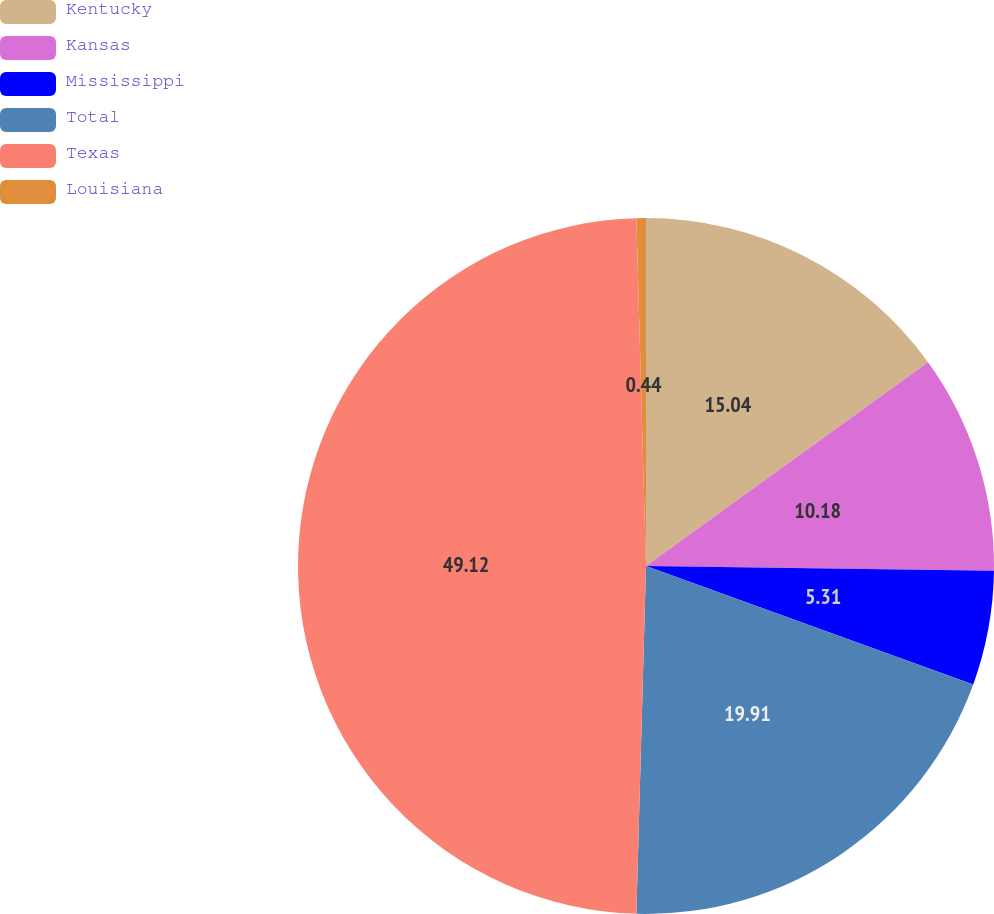Convert chart. <chart><loc_0><loc_0><loc_500><loc_500><pie_chart><fcel>Kentucky<fcel>Kansas<fcel>Mississippi<fcel>Total<fcel>Texas<fcel>Louisiana<nl><fcel>15.04%<fcel>10.18%<fcel>5.31%<fcel>19.91%<fcel>49.12%<fcel>0.44%<nl></chart> 